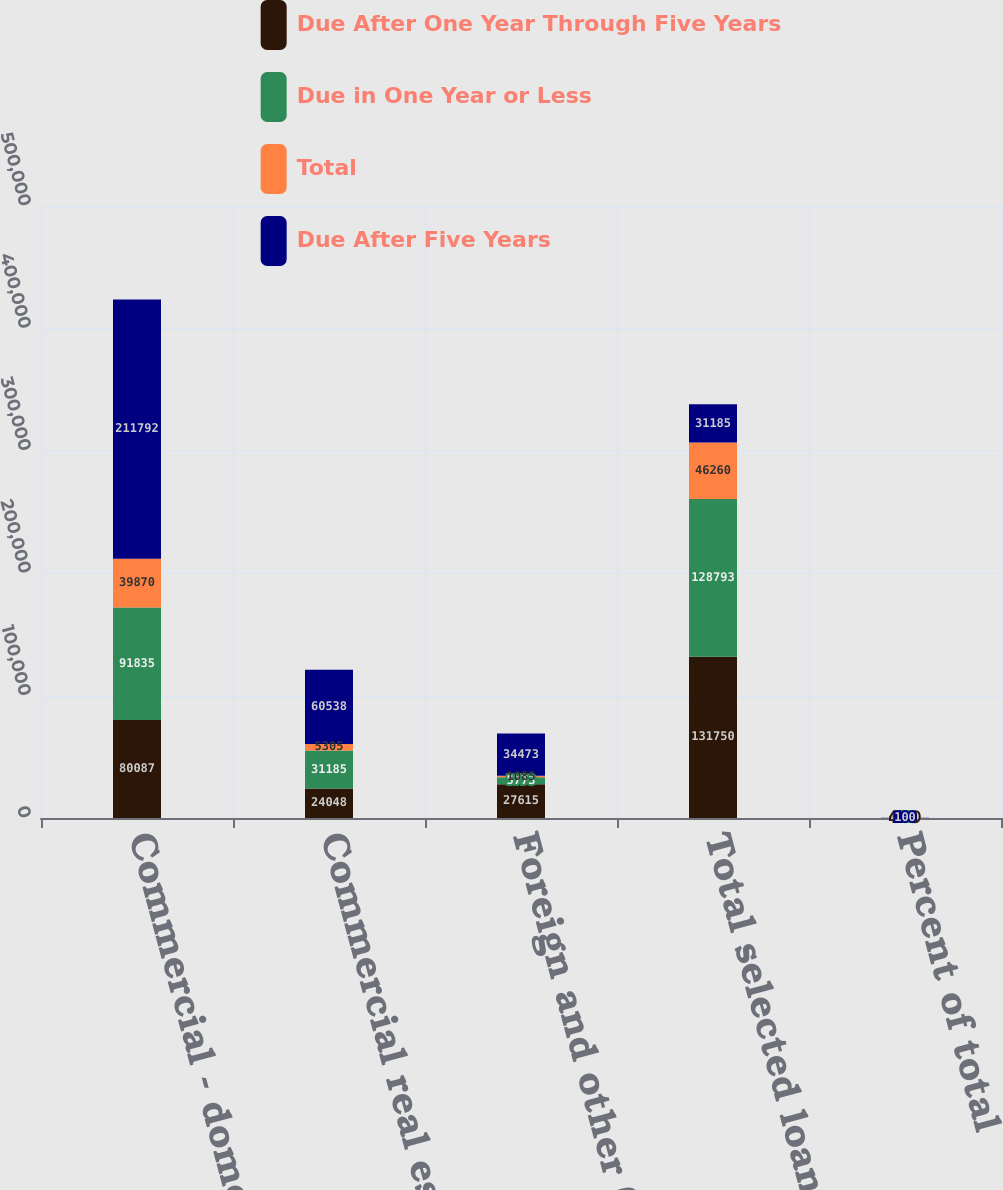Convert chart. <chart><loc_0><loc_0><loc_500><loc_500><stacked_bar_chart><ecel><fcel>Commercial - domestic<fcel>Commercial real estate -<fcel>Foreign and other (3)<fcel>Total selected loans<fcel>Percent of total<nl><fcel>Due After One Year Through Five Years<fcel>80087<fcel>24048<fcel>27615<fcel>131750<fcel>42.9<nl><fcel>Due in One Year or Less<fcel>91835<fcel>31185<fcel>5773<fcel>128793<fcel>42<nl><fcel>Total<fcel>39870<fcel>5305<fcel>1085<fcel>46260<fcel>15.1<nl><fcel>Due After Five Years<fcel>211792<fcel>60538<fcel>34473<fcel>31185<fcel>100<nl></chart> 